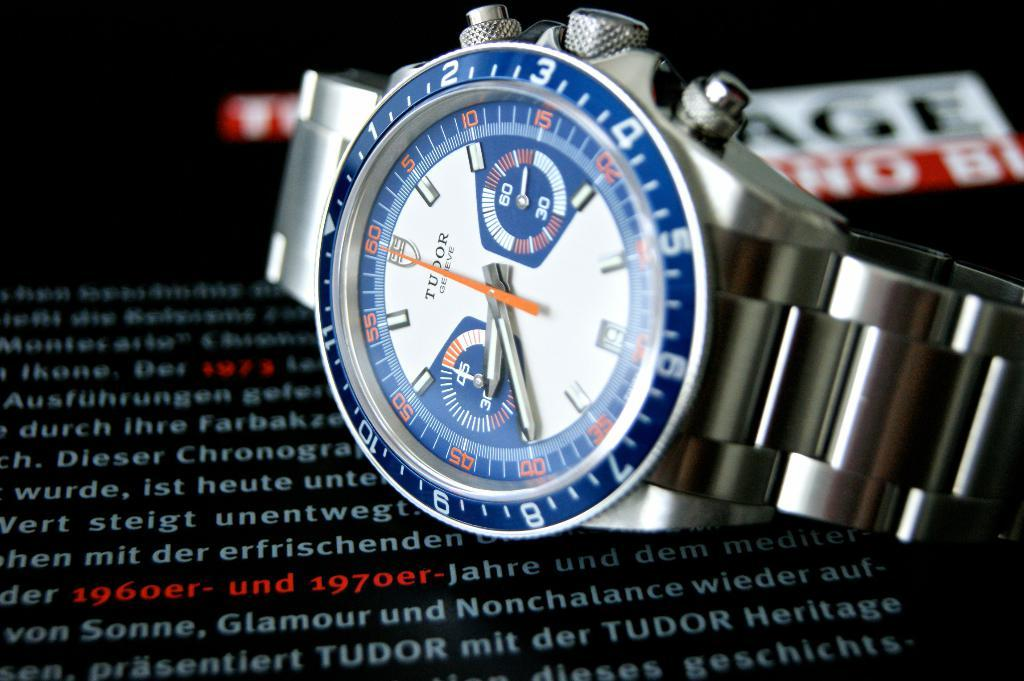Provide a one-sentence caption for the provided image. A Tudor watch sitting on an advertisement stating it was made between 1960 and 1970. 